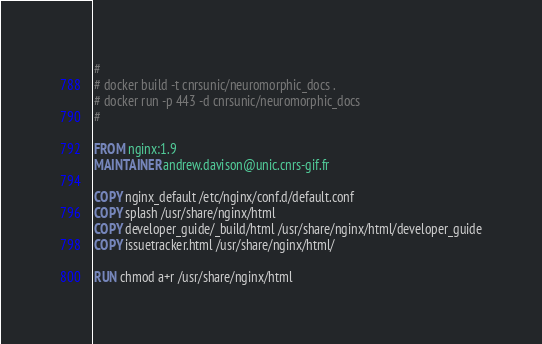Convert code to text. <code><loc_0><loc_0><loc_500><loc_500><_Dockerfile_>#
# docker build -t cnrsunic/neuromorphic_docs .
# docker run -p 443 -d cnrsunic/neuromorphic_docs
#

FROM nginx:1.9
MAINTAINER andrew.davison@unic.cnrs-gif.fr

COPY nginx_default /etc/nginx/conf.d/default.conf
COPY splash /usr/share/nginx/html
COPY developer_guide/_build/html /usr/share/nginx/html/developer_guide
COPY issuetracker.html /usr/share/nginx/html/

RUN chmod a+r /usr/share/nginx/html
</code> 